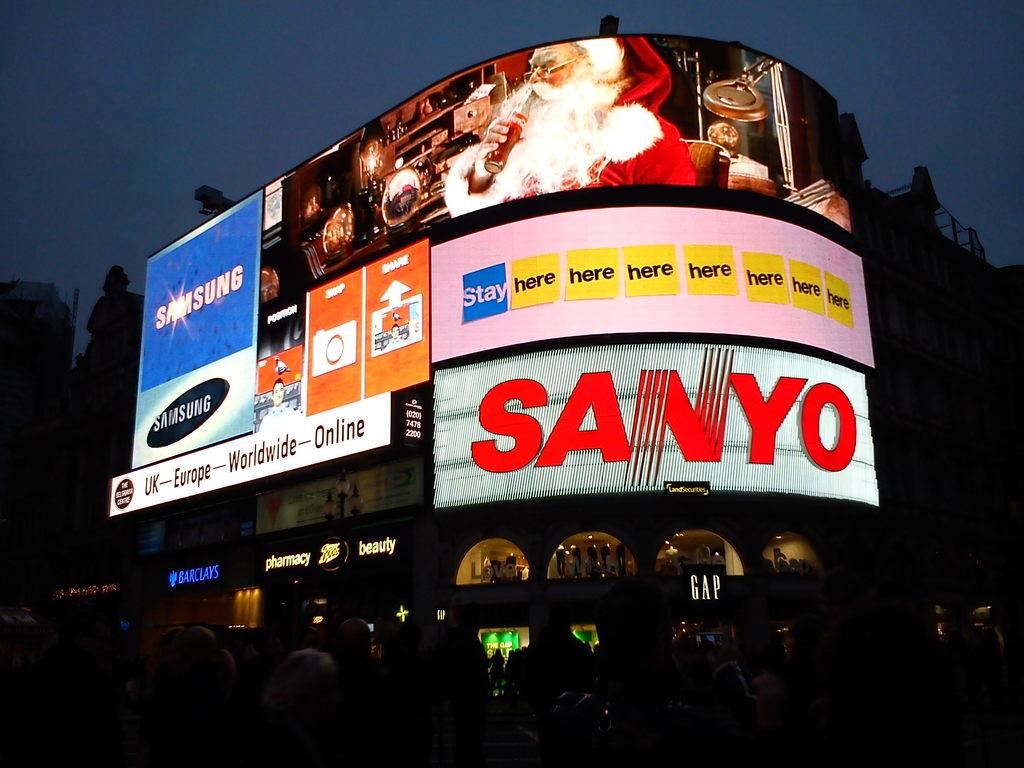What companies are advertising here?
Offer a terse response. Sanyo, samsung. How many companies are being shown in the billboard?
Offer a very short reply. 2. 